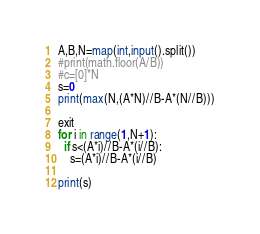<code> <loc_0><loc_0><loc_500><loc_500><_Python_>A,B,N=map(int,input().split())
#print(math.floor(A/B))
#c=[0]*N
s=0
print(max(N,(A*N)//B-A*(N//B)))

exit
for i in range(1,N+1):
  if s<(A*i)//B-A*(i//B):
    s=(A*i)//B-A*(i//B)

print(s)</code> 